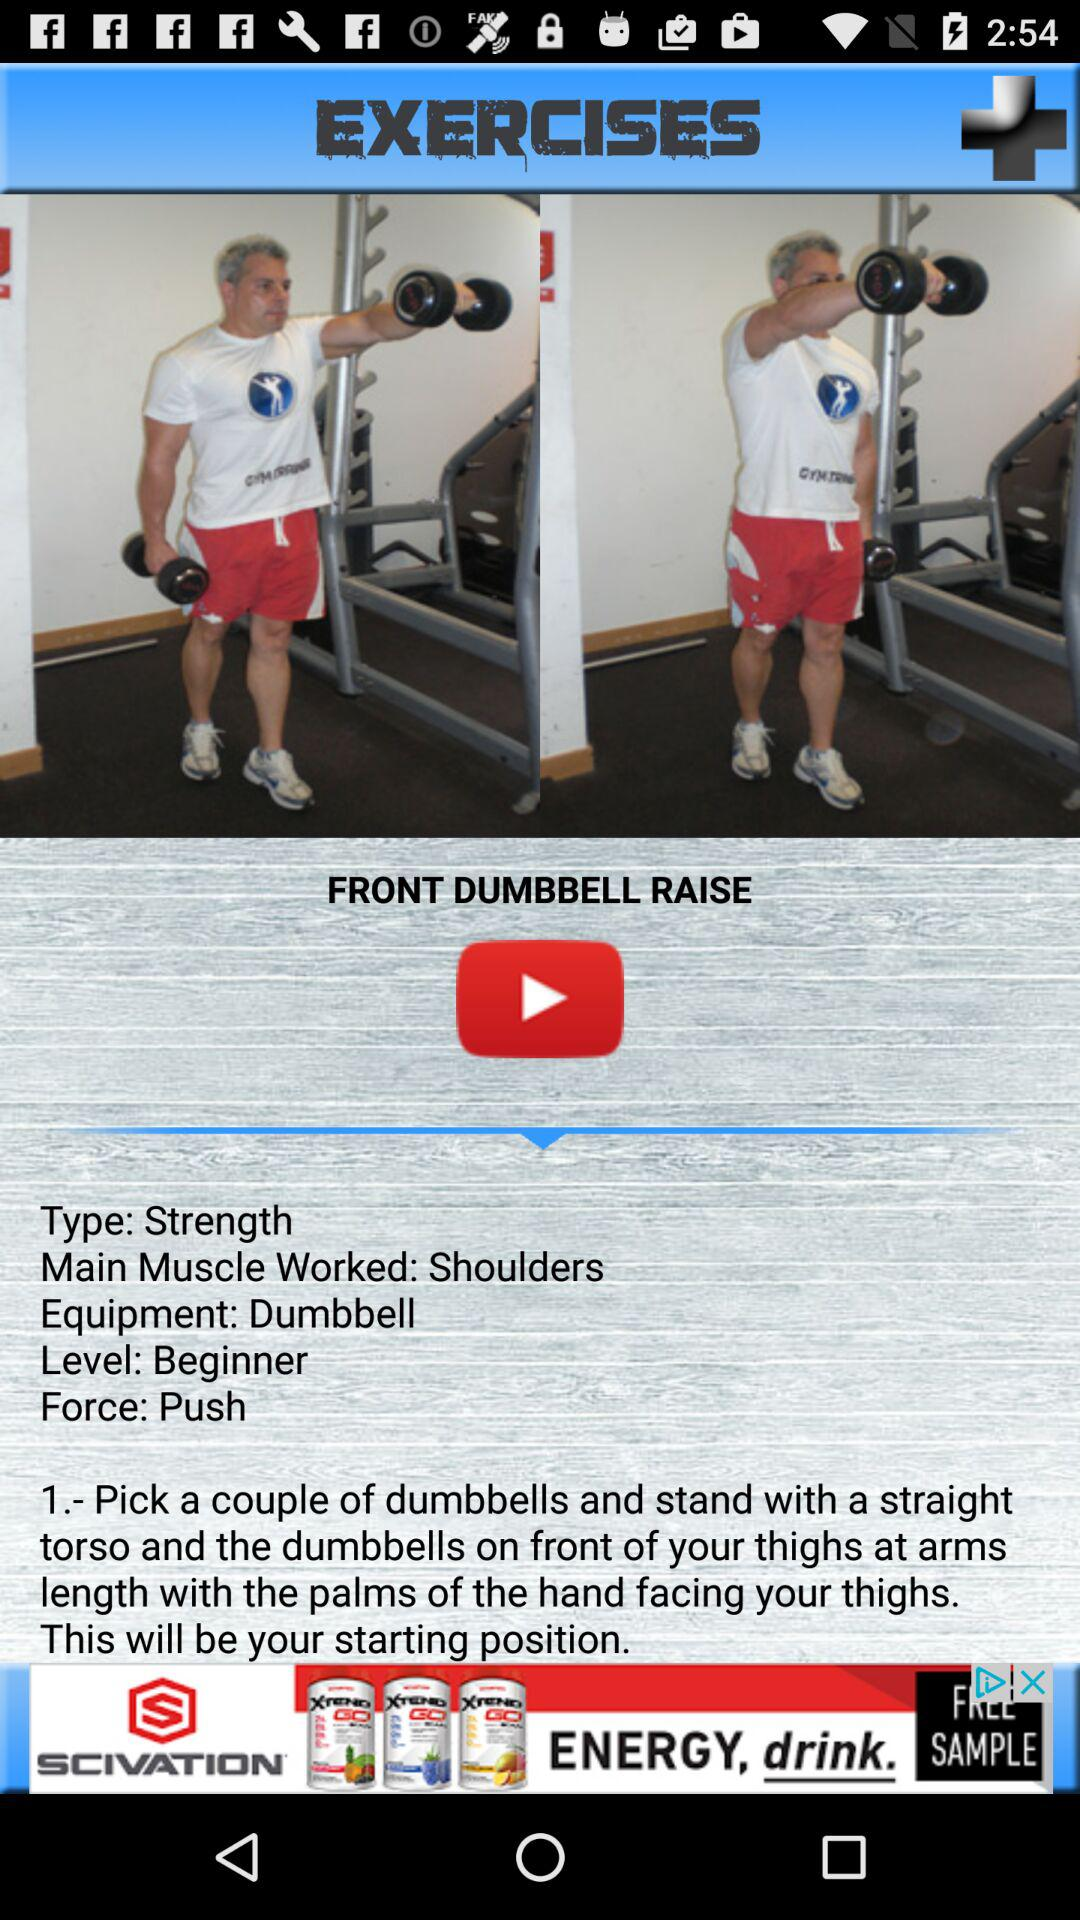What equipment is used? The used equipment is a dumbbell. 